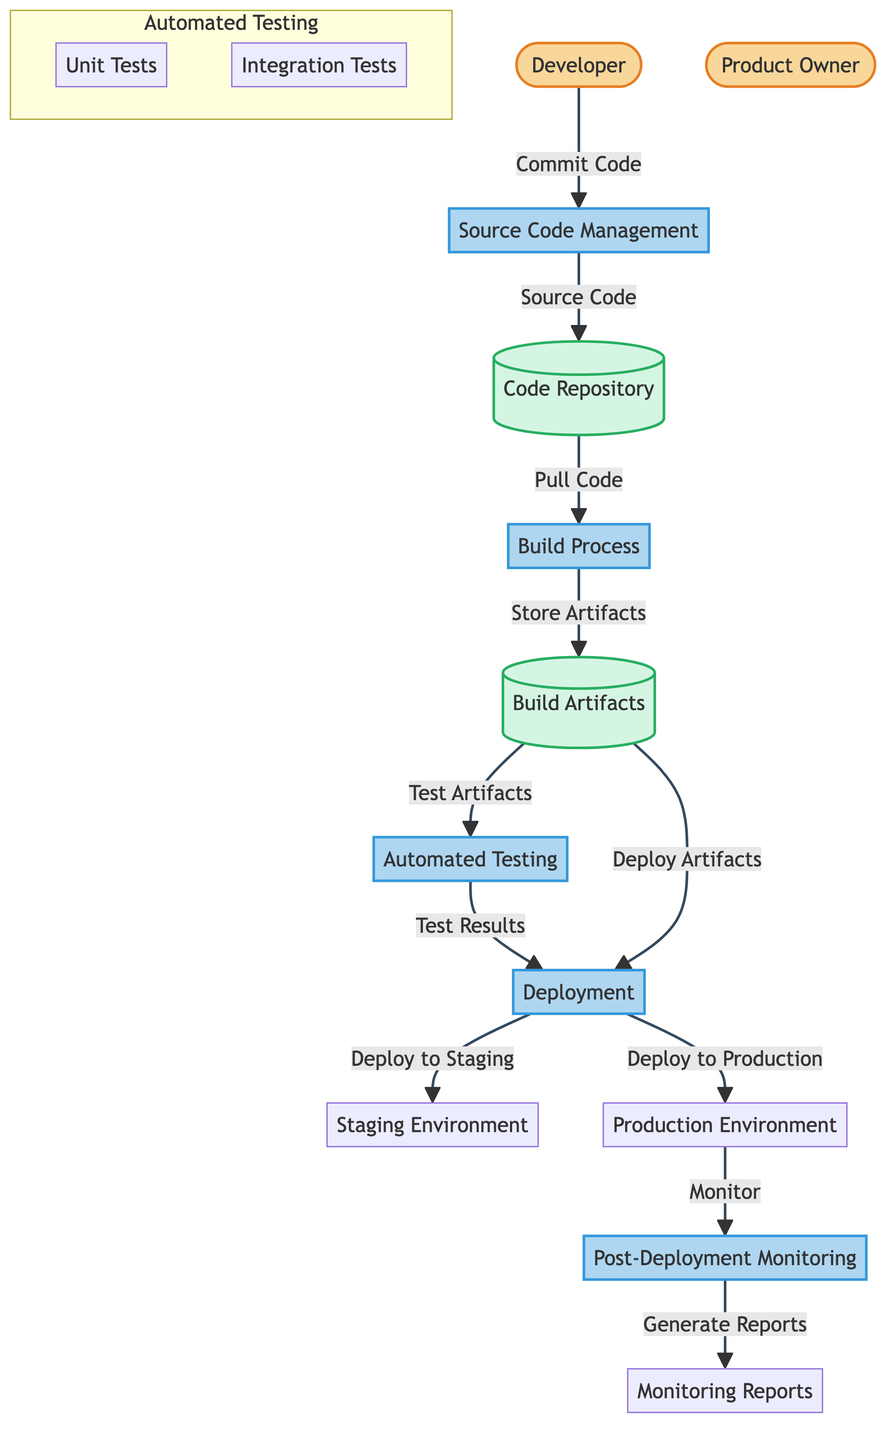What are the external entities in this diagram? The diagram shows two external entities: Developer and Product Owner. These represent the roles involved in the CI/CD workflow, specifically the individual or team responsible for coding and the person overseeing product requirements.
Answer: Developer, Product Owner What is the output of the Build Process? The output from the Build Process is the Build Artifacts, which are the files and products created when the application is built from the source code.
Answer: Build Artifacts How many processes are depicted in the diagram? The diagram features five main processes: Source Code Management, Build Process, Automated Testing, Deployment, and Post-Deployment Monitoring. Counting these gives a total of five.
Answer: Five Which entity is responsible for committing code? The Developer is the entity mentioned in the diagram that is responsible for committing code to the Source Code Management process.
Answer: Developer What data flow is shown from the Automated Testing process to Deployment? The data flow is described as "Test Results evaluated for deployment," which indicates that the outcomes from Automated Testing are crucial for deciding if Deployment can proceed.
Answer: Test Results evaluated for deployment What stores the source code in this workflow? The Code Repository is the data store that maintains and manages the source code, keeping track of versions and changes made by developers.
Answer: Code Repository What are the outputs of the Deployment process? The outputs of the Deployment process are Staging Environment and Production Environment, indicating the environments where the application is deployed after successful testing.
Answer: Staging Environment, Production Environment What is the purpose of the Post-Deployment Monitoring process? The purpose of the Post-Deployment Monitoring process is to monitor the application in the Production Environment for any issues and to evaluate its performance after deployment.
Answer: Monitor application How do Build Artifacts interact with the Automated Testing process? The Build Artifacts are tested by the Automated Testing process, which ensures that the new changes do not disrupt existing functionalities. Specifically, they flow into Automated Testing, which is responsible for executing various tests.
Answer: Build Artifacts tested 